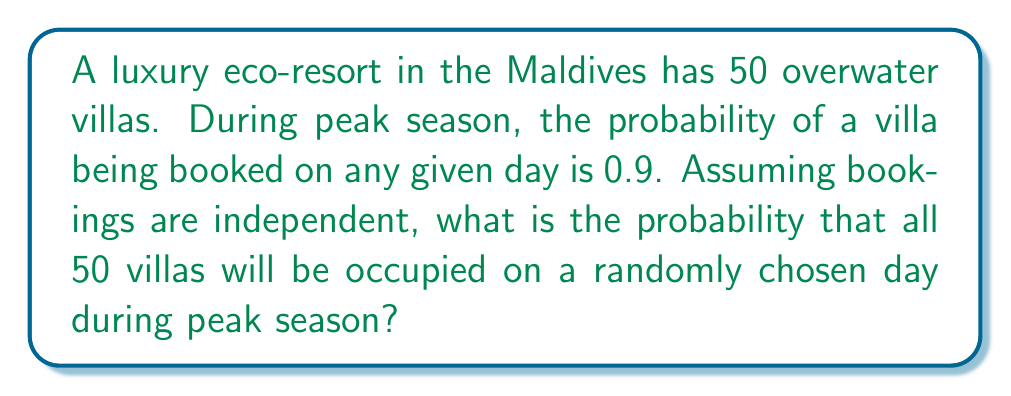Teach me how to tackle this problem. Let's approach this step-by-step:

1) First, we need to recognize that this is a binomial probability problem. We're looking for the probability of 50 successes (all villas booked) out of 50 trials.

2) The probability of a single villa being booked is 0.9, so the probability of all 50 villas being booked is the product of 50 individual probabilities:

   $$P(\text{all 50 booked}) = 0.9^{50}$$

3) Let's calculate this:
   
   $$0.9^{50} = (0.9 \times 0.9 \times ... \times 0.9) \text{ (50 times)}$$

4) Using a calculator or computer:

   $$0.9^{50} \approx 0.005153775$$

5) Converting to a percentage:

   $$0.005153775 \times 100\% \approx 0.5154\%$$

Therefore, the probability of all 50 villas being occupied on a randomly chosen day during peak season is approximately 0.5154% or about 1 in 194 days.
Answer: $0.9^{50} \approx 0.005154$ or $0.5154\%$ 